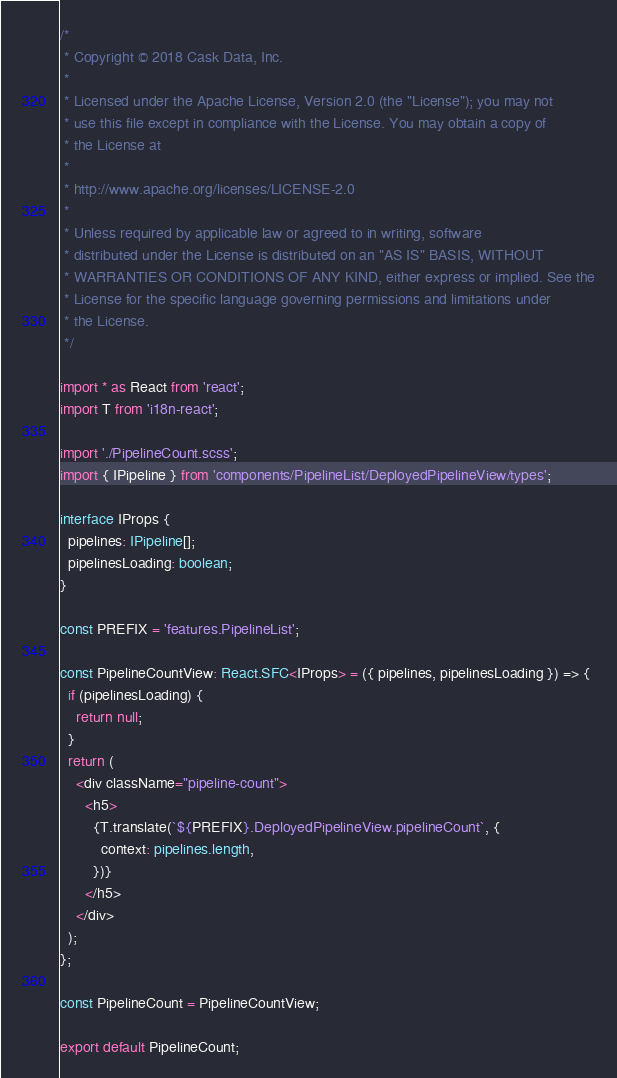<code> <loc_0><loc_0><loc_500><loc_500><_TypeScript_>/*
 * Copyright © 2018 Cask Data, Inc.
 *
 * Licensed under the Apache License, Version 2.0 (the "License"); you may not
 * use this file except in compliance with the License. You may obtain a copy of
 * the License at
 *
 * http://www.apache.org/licenses/LICENSE-2.0
 *
 * Unless required by applicable law or agreed to in writing, software
 * distributed under the License is distributed on an "AS IS" BASIS, WITHOUT
 * WARRANTIES OR CONDITIONS OF ANY KIND, either express or implied. See the
 * License for the specific language governing permissions and limitations under
 * the License.
 */

import * as React from 'react';
import T from 'i18n-react';

import './PipelineCount.scss';
import { IPipeline } from 'components/PipelineList/DeployedPipelineView/types';

interface IProps {
  pipelines: IPipeline[];
  pipelinesLoading: boolean;
}

const PREFIX = 'features.PipelineList';

const PipelineCountView: React.SFC<IProps> = ({ pipelines, pipelinesLoading }) => {
  if (pipelinesLoading) {
    return null;
  }
  return (
    <div className="pipeline-count">
      <h5>
        {T.translate(`${PREFIX}.DeployedPipelineView.pipelineCount`, {
          context: pipelines.length,
        })}
      </h5>
    </div>
  );
};

const PipelineCount = PipelineCountView;

export default PipelineCount;
</code> 